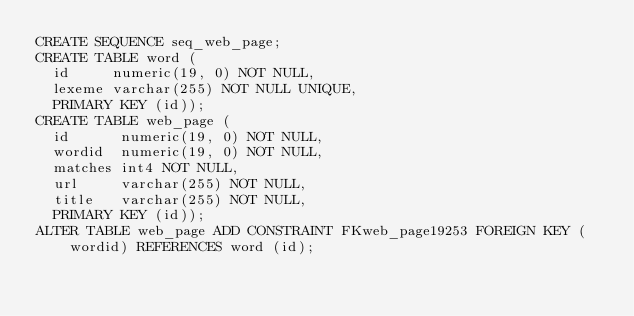Convert code to text. <code><loc_0><loc_0><loc_500><loc_500><_SQL_>CREATE SEQUENCE seq_web_page;
CREATE TABLE word (
  id     numeric(19, 0) NOT NULL, 
  lexeme varchar(255) NOT NULL UNIQUE, 
  PRIMARY KEY (id));
CREATE TABLE web_page (
  id      numeric(19, 0) NOT NULL, 
  wordid  numeric(19, 0) NOT NULL, 
  matches int4 NOT NULL, 
  url     varchar(255) NOT NULL, 
  title   varchar(255) NOT NULL, 
  PRIMARY KEY (id));
ALTER TABLE web_page ADD CONSTRAINT FKweb_page19253 FOREIGN KEY (wordid) REFERENCES word (id);
</code> 